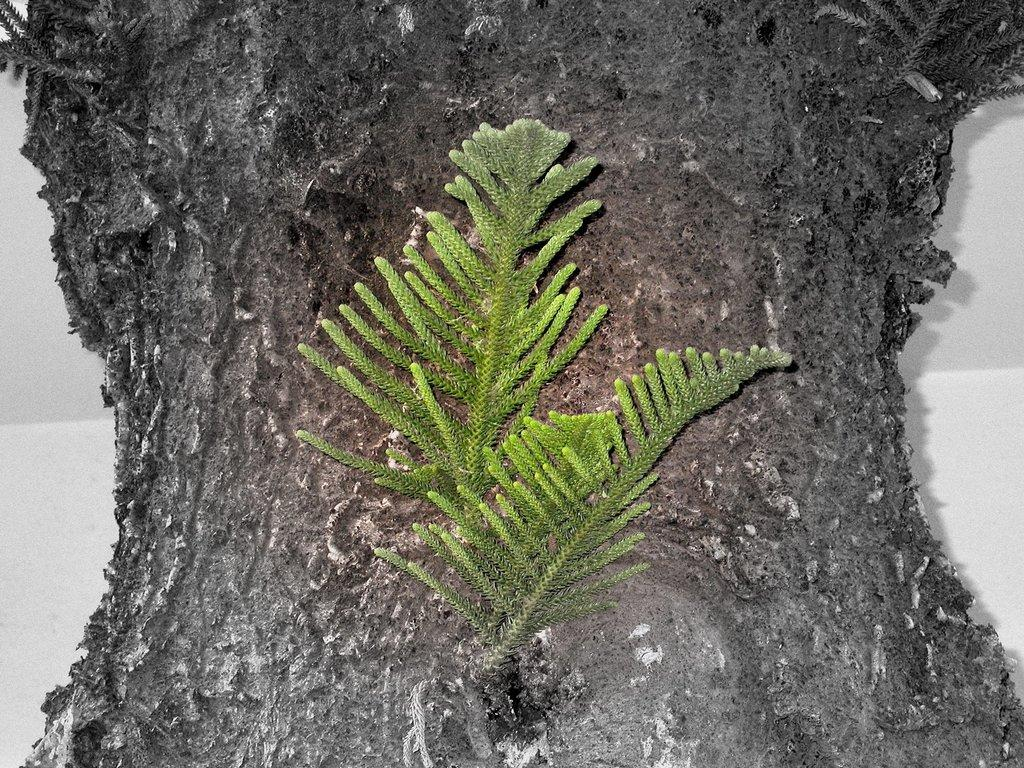What is located in the center of the image? There are leaves in the center of the image. What can be seen in the background of the image? There is a tree trunk and a wall in the background of the image. How many legs can be seen on the lizards in the image? There are no lizards present in the image, so it is not possible to determine the number of legs they might have. 